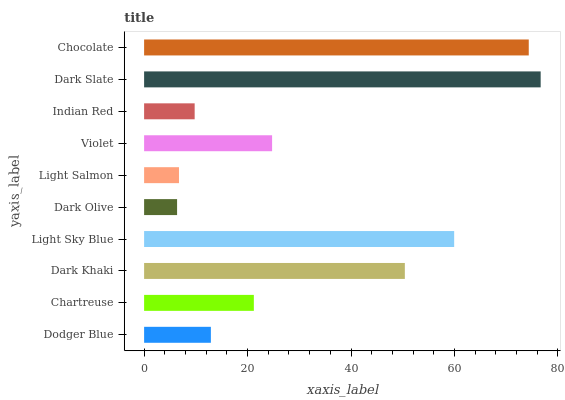Is Dark Olive the minimum?
Answer yes or no. Yes. Is Dark Slate the maximum?
Answer yes or no. Yes. Is Chartreuse the minimum?
Answer yes or no. No. Is Chartreuse the maximum?
Answer yes or no. No. Is Chartreuse greater than Dodger Blue?
Answer yes or no. Yes. Is Dodger Blue less than Chartreuse?
Answer yes or no. Yes. Is Dodger Blue greater than Chartreuse?
Answer yes or no. No. Is Chartreuse less than Dodger Blue?
Answer yes or no. No. Is Violet the high median?
Answer yes or no. Yes. Is Chartreuse the low median?
Answer yes or no. Yes. Is Dodger Blue the high median?
Answer yes or no. No. Is Chocolate the low median?
Answer yes or no. No. 